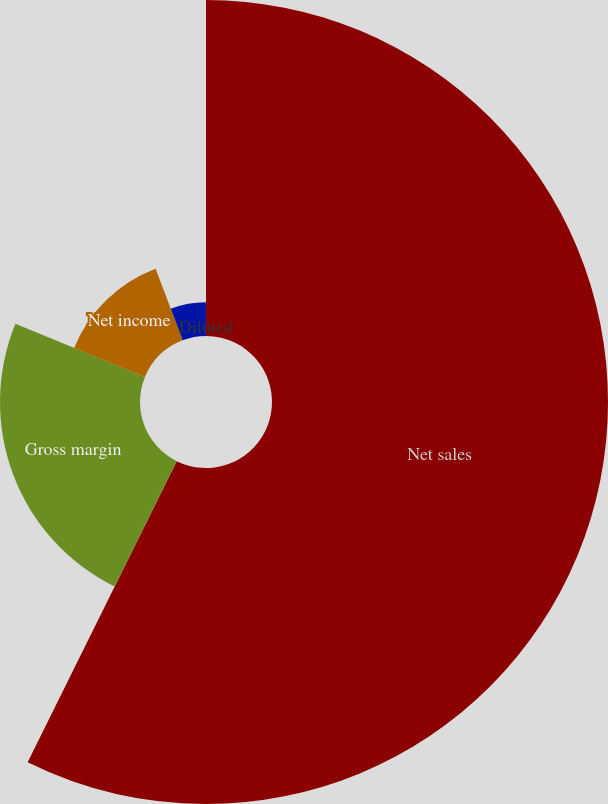Convert chart. <chart><loc_0><loc_0><loc_500><loc_500><pie_chart><fcel>Net sales<fcel>Gross margin<fcel>Net income<fcel>Basic<fcel>Diluted<nl><fcel>57.31%<fcel>23.88%<fcel>13.05%<fcel>5.74%<fcel>0.01%<nl></chart> 